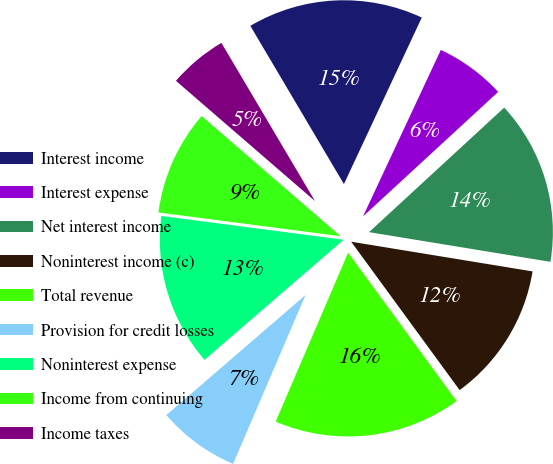<chart> <loc_0><loc_0><loc_500><loc_500><pie_chart><fcel>Interest income<fcel>Interest expense<fcel>Net interest income<fcel>Noninterest income (c)<fcel>Total revenue<fcel>Provision for credit losses<fcel>Noninterest expense<fcel>Income from continuing<fcel>Income taxes<nl><fcel>15.46%<fcel>6.19%<fcel>14.43%<fcel>12.37%<fcel>16.49%<fcel>7.22%<fcel>13.4%<fcel>9.28%<fcel>5.15%<nl></chart> 